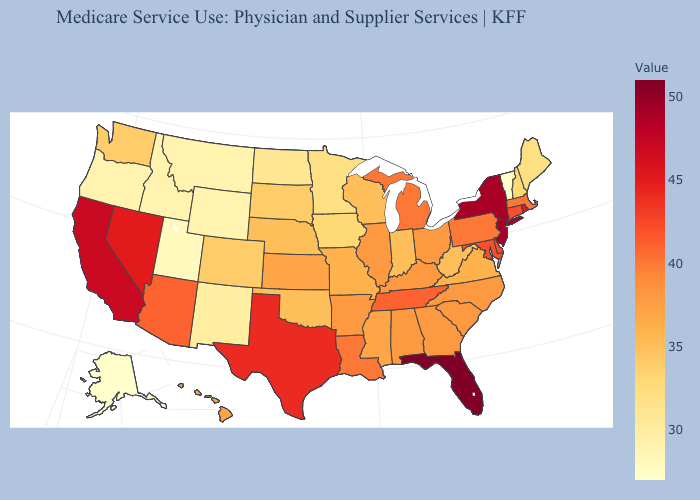Which states have the lowest value in the West?
Answer briefly. Alaska. Among the states that border Maryland , which have the highest value?
Answer briefly. Delaware. Does the map have missing data?
Concise answer only. No. Does Illinois have a lower value than Maine?
Concise answer only. No. Does Wisconsin have a lower value than Vermont?
Write a very short answer. No. 